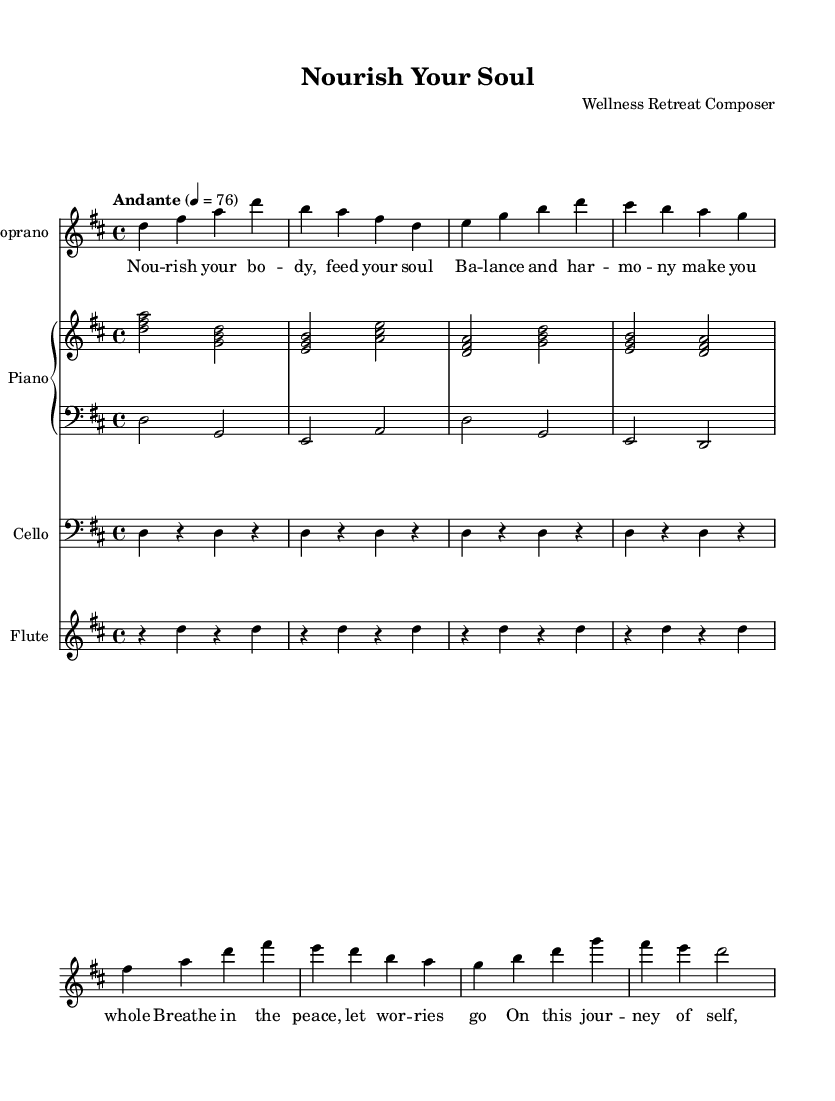What is the key signature of this music? The key signature is D major, which has two sharps (F# and C#). This can be identified at the beginning of the staff where the sharps are notated.
Answer: D major What is the time signature of this piece? The time signature is 4/4, indicated at the beginning of the music sheet after the key signature. This means there are four beats in a measure and the quarter note gets one beat.
Answer: 4/4 What is the tempo marking for this composition? The tempo marking is "Andante," which indicates a moderate pace. This is also seen at the top of the music sheet as a performance direction.
Answer: Andante How many instruments are featured in this score? The score features four instruments: a soprano, piano (with right and left parts), cello, and flute. This can be determined by counting the distinct musical staves present in the score.
Answer: Four What mood is expressed through the lyrics of this piece? The mood expressed is one of nourishment and growth, emphasizing peace, balance, and self-improvement. This can be inferred from the lyrics that mention feeding the soul and letting worries go.
Answer: Nourishment and growth Which voice part has lyrics attached? The soprano voice has lyrics attached, as indicated by the lyric mode directly aligned with the soprano melody in the score.
Answer: Soprano What is the dynamic marking for the cello part? The cello part does not have a specific dynamic marking indicated in the sheet music. This indicates a performance freedom for the player, often being up to their interpretation unless directed otherwise.
Answer: None 